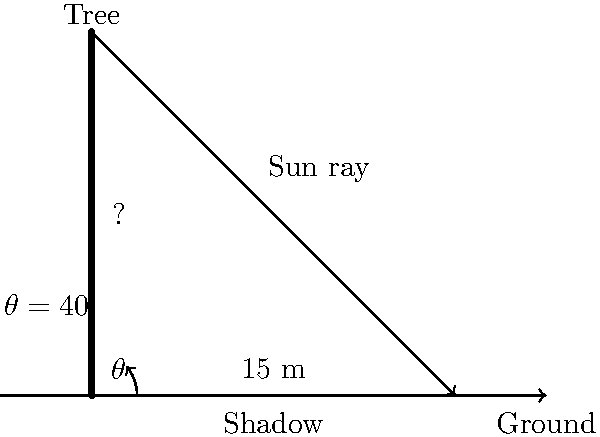During your commute, you and your office buddy decide to tackle a trigonometry problem to pass the time. You see a tree casting a shadow on the ground and wonder about its height. If the shadow is 15 meters long and the angle of elevation of the sun is 40°, how tall is the tree? Round your answer to the nearest tenth of a meter. Let's approach this step-by-step:

1) In this problem, we have a right triangle formed by the tree, its shadow, and the sun ray.

2) We know:
   - The length of the shadow (adjacent side) = 15 meters
   - The angle of elevation of the sun = 40°

3) We need to find the height of the tree, which is the opposite side in this triangle.

4) This is a perfect scenario to use the tangent function, as we have the adjacent side and need to find the opposite side.

5) The formula for tangent is:
   $\tan \theta = \frac{\text{opposite}}{\text{adjacent}}$

6) Plugging in our values:
   $\tan 40° = \frac{\text{tree height}}{15}$

7) To solve for the tree height, we multiply both sides by 15:
   $15 \cdot \tan 40° = \text{tree height}$

8) Now, let's calculate:
   $\text{tree height} = 15 \cdot \tan 40°$
   $= 15 \cdot 0.8391$
   $= 12.5865$ meters

9) Rounding to the nearest tenth:
   $\text{tree height} \approx 12.6$ meters
Answer: 12.6 meters 